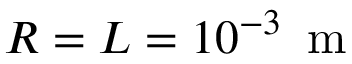Convert formula to latex. <formula><loc_0><loc_0><loc_500><loc_500>R = L = 1 0 ^ { - 3 } \, m</formula> 